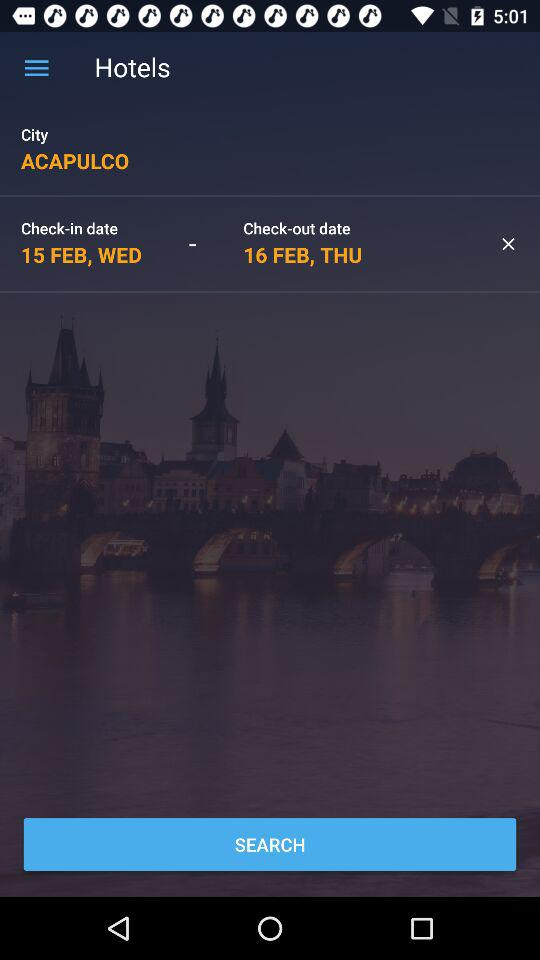How many days are between the check-in and check-out dates?
Answer the question using a single word or phrase. 1 